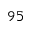Convert formula to latex. <formula><loc_0><loc_0><loc_500><loc_500>9 5</formula> 